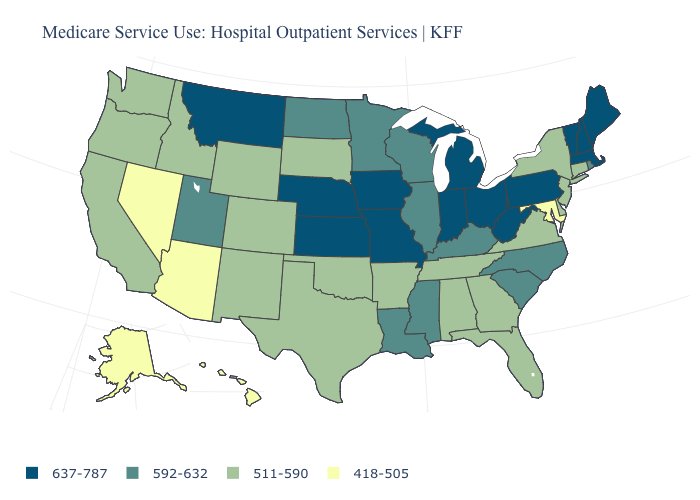Name the states that have a value in the range 511-590?
Give a very brief answer. Alabama, Arkansas, California, Colorado, Connecticut, Delaware, Florida, Georgia, Idaho, New Jersey, New Mexico, New York, Oklahoma, Oregon, South Dakota, Tennessee, Texas, Virginia, Washington, Wyoming. What is the value of New Hampshire?
Be succinct. 637-787. Does South Dakota have the lowest value in the MidWest?
Write a very short answer. Yes. What is the lowest value in the USA?
Answer briefly. 418-505. Does Wyoming have a lower value than South Carolina?
Be succinct. Yes. Which states hav the highest value in the South?
Answer briefly. West Virginia. Does the first symbol in the legend represent the smallest category?
Short answer required. No. Which states have the lowest value in the West?
Be succinct. Alaska, Arizona, Hawaii, Nevada. Among the states that border Utah , which have the lowest value?
Be succinct. Arizona, Nevada. Name the states that have a value in the range 511-590?
Give a very brief answer. Alabama, Arkansas, California, Colorado, Connecticut, Delaware, Florida, Georgia, Idaho, New Jersey, New Mexico, New York, Oklahoma, Oregon, South Dakota, Tennessee, Texas, Virginia, Washington, Wyoming. Does Tennessee have a lower value than Hawaii?
Write a very short answer. No. What is the value of Wisconsin?
Quick response, please. 592-632. Among the states that border Indiana , which have the highest value?
Short answer required. Michigan, Ohio. Among the states that border Texas , which have the lowest value?
Write a very short answer. Arkansas, New Mexico, Oklahoma. Among the states that border Tennessee , does Missouri have the lowest value?
Concise answer only. No. 